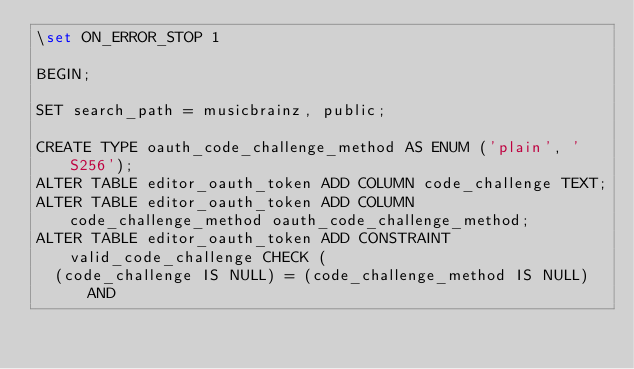Convert code to text. <code><loc_0><loc_0><loc_500><loc_500><_SQL_>\set ON_ERROR_STOP 1

BEGIN;

SET search_path = musicbrainz, public;

CREATE TYPE oauth_code_challenge_method AS ENUM ('plain', 'S256');
ALTER TABLE editor_oauth_token ADD COLUMN code_challenge TEXT;
ALTER TABLE editor_oauth_token ADD COLUMN code_challenge_method oauth_code_challenge_method;
ALTER TABLE editor_oauth_token ADD CONSTRAINT valid_code_challenge CHECK (
  (code_challenge IS NULL) = (code_challenge_method IS NULL) AND</code> 